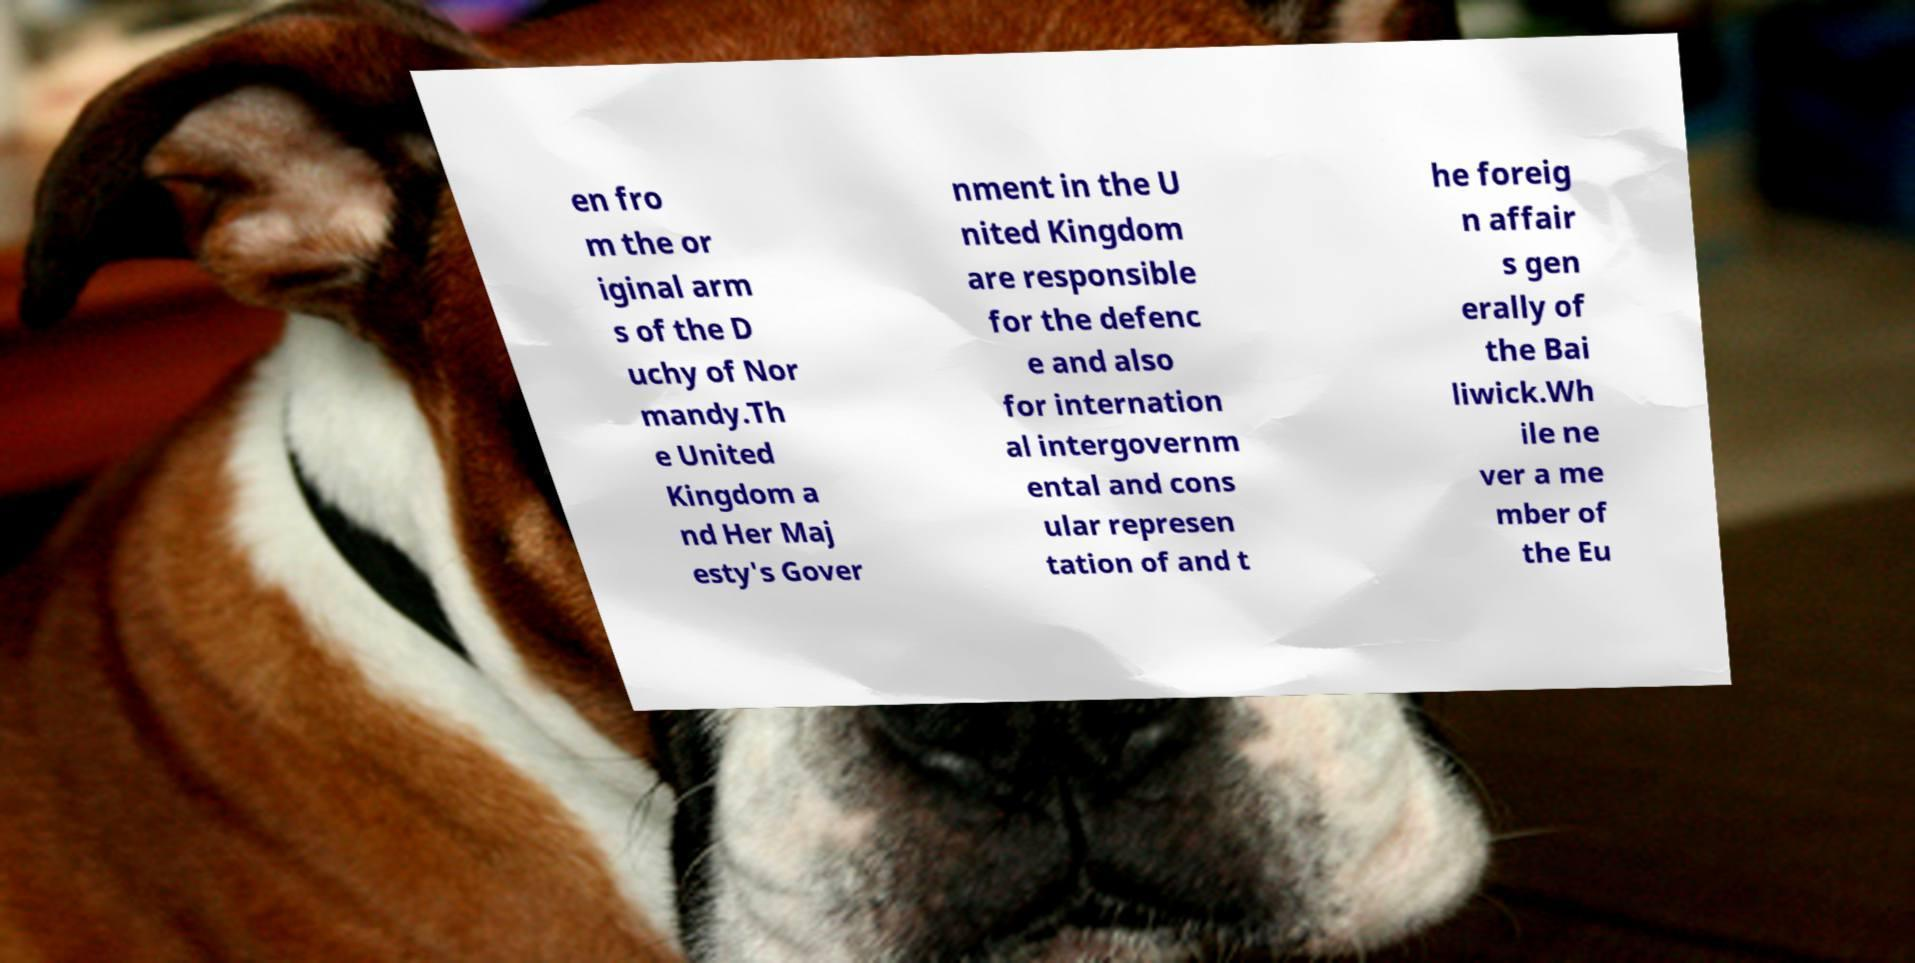Could you assist in decoding the text presented in this image and type it out clearly? en fro m the or iginal arm s of the D uchy of Nor mandy.Th e United Kingdom a nd Her Maj esty's Gover nment in the U nited Kingdom are responsible for the defenc e and also for internation al intergovernm ental and cons ular represen tation of and t he foreig n affair s gen erally of the Bai liwick.Wh ile ne ver a me mber of the Eu 